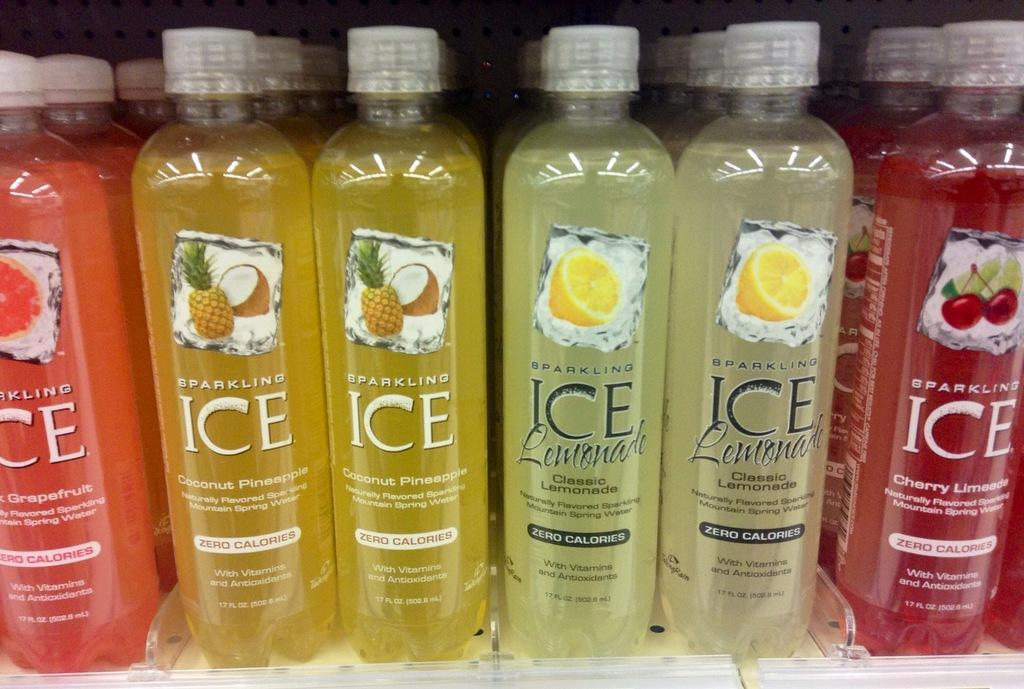<image>
Provide a brief description of the given image. Different bottles of Sparkling Ice are on a shelf. 